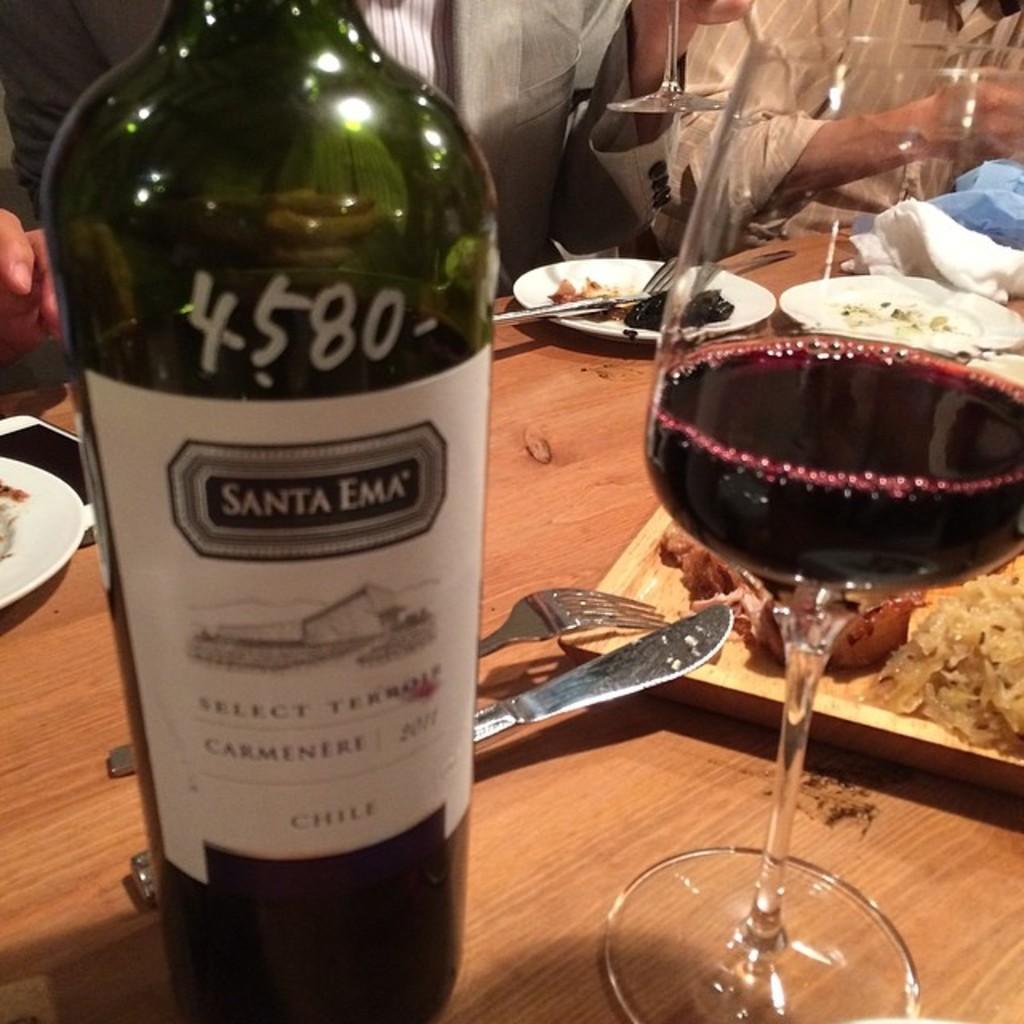What's the name of this wine?
Offer a very short reply. Santa ema. 